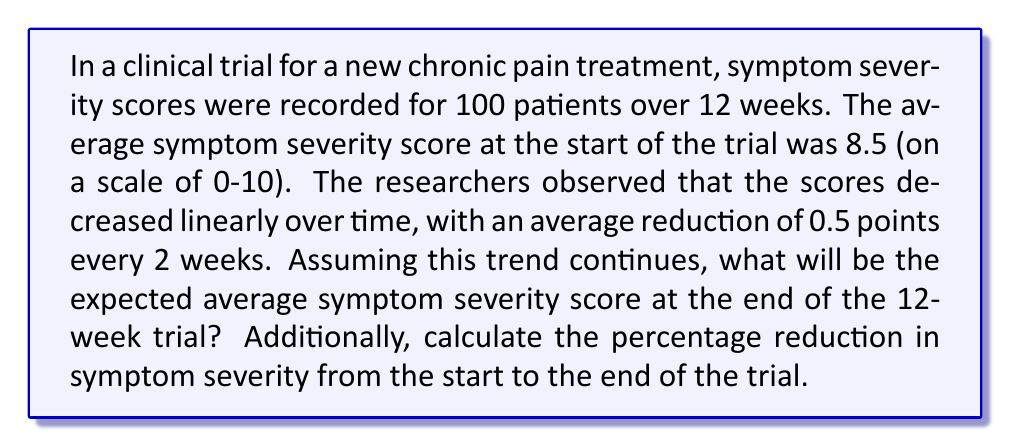Can you solve this math problem? To solve this problem, we need to follow these steps:

1. Calculate the rate of decrease per week:
   The score decreases by 0.5 points every 2 weeks.
   Rate of decrease per week = $\frac{0.5}{2} = 0.25$ points/week

2. Calculate the total decrease over 12 weeks:
   Total decrease = Rate of decrease × Number of weeks
   $$ \text{Total decrease} = 0.25 \times 12 = 3 \text{ points} $$

3. Calculate the expected average symptom severity score at the end of the trial:
   Final score = Initial score - Total decrease
   $$ \text{Final score} = 8.5 - 3 = 5.5 $$

4. Calculate the percentage reduction:
   Percentage reduction = $\frac{\text{Total decrease}}{\text{Initial score}} \times 100\%$
   $$ \text{Percentage reduction} = \frac{3}{8.5} \times 100\% \approx 35.29\% $$

Therefore, the expected average symptom severity score at the end of the 12-week trial will be 5.5, and the percentage reduction in symptom severity from the start to the end of the trial is approximately 35.29%.
Answer: The expected average symptom severity score at the end of the 12-week trial is 5.5, and the percentage reduction in symptom severity is approximately 35.29%. 